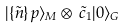Convert formula to latex. <formula><loc_0><loc_0><loc_500><loc_500>| \{ \tilde { n } \} \, p \rangle _ { M } \otimes \, \tilde { c } _ { 1 } | 0 \rangle _ { G }</formula> 